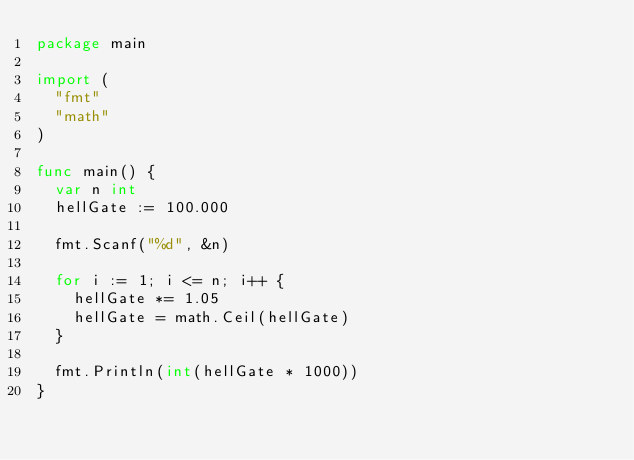<code> <loc_0><loc_0><loc_500><loc_500><_Go_>package main

import (
	"fmt"
	"math"
)

func main() {
	var n int
	hellGate := 100.000

	fmt.Scanf("%d", &n)

	for i := 1; i <= n; i++ {
		hellGate *= 1.05
		hellGate = math.Ceil(hellGate)
	}

	fmt.Println(int(hellGate * 1000))
}

</code> 